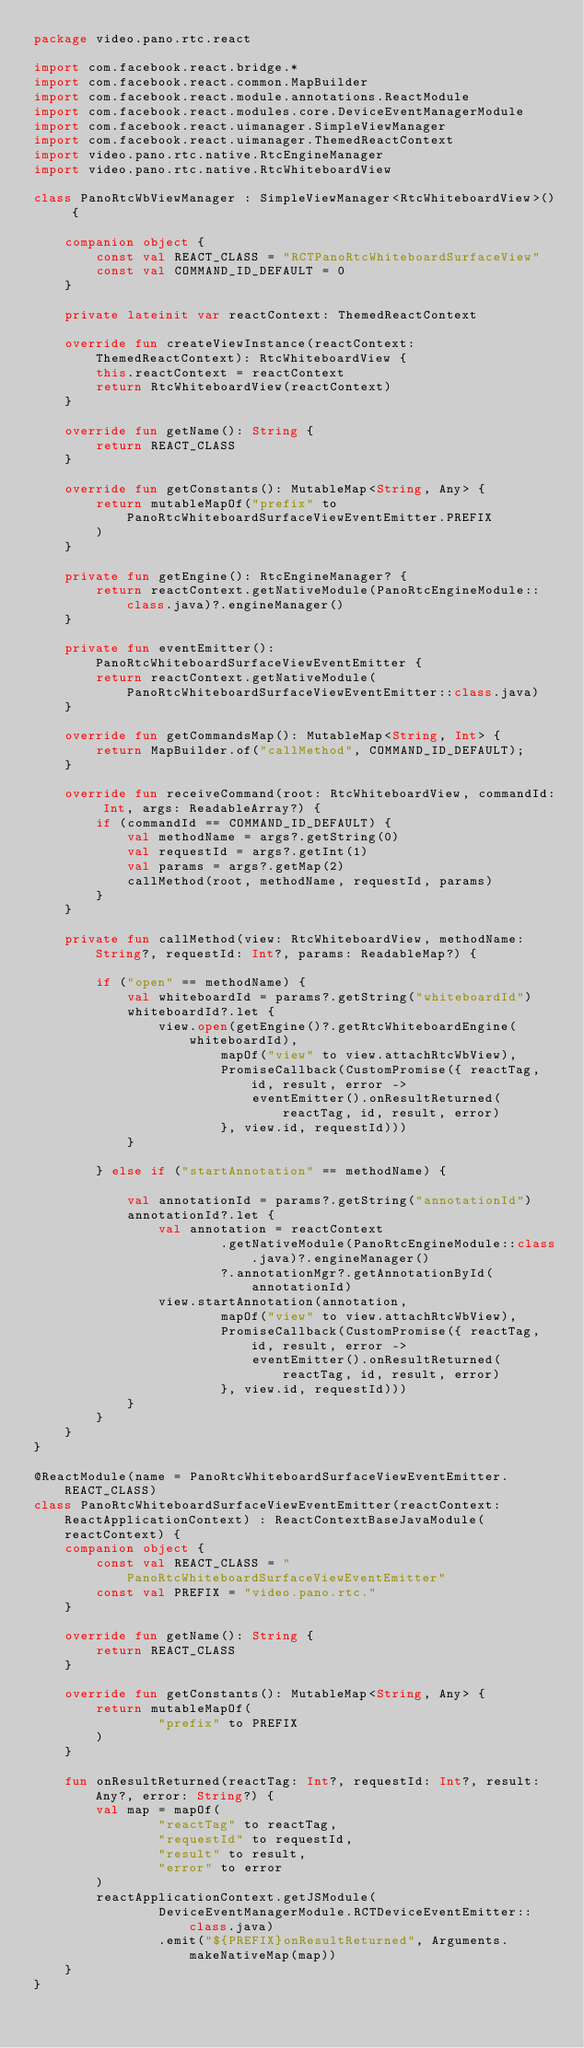<code> <loc_0><loc_0><loc_500><loc_500><_Kotlin_>package video.pano.rtc.react

import com.facebook.react.bridge.*
import com.facebook.react.common.MapBuilder
import com.facebook.react.module.annotations.ReactModule
import com.facebook.react.modules.core.DeviceEventManagerModule
import com.facebook.react.uimanager.SimpleViewManager
import com.facebook.react.uimanager.ThemedReactContext
import video.pano.rtc.native.RtcEngineManager
import video.pano.rtc.native.RtcWhiteboardView

class PanoRtcWbViewManager : SimpleViewManager<RtcWhiteboardView>() {

    companion object {
        const val REACT_CLASS = "RCTPanoRtcWhiteboardSurfaceView"
        const val COMMAND_ID_DEFAULT = 0
    }

    private lateinit var reactContext: ThemedReactContext

    override fun createViewInstance(reactContext: ThemedReactContext): RtcWhiteboardView {
        this.reactContext = reactContext
        return RtcWhiteboardView(reactContext)
    }

    override fun getName(): String {
        return REACT_CLASS
    }

    override fun getConstants(): MutableMap<String, Any> {
        return mutableMapOf("prefix" to PanoRtcWhiteboardSurfaceViewEventEmitter.PREFIX
        )
    }

    private fun getEngine(): RtcEngineManager? {
        return reactContext.getNativeModule(PanoRtcEngineModule::class.java)?.engineManager()
    }

    private fun eventEmitter(): PanoRtcWhiteboardSurfaceViewEventEmitter {
        return reactContext.getNativeModule(PanoRtcWhiteboardSurfaceViewEventEmitter::class.java)
    }

    override fun getCommandsMap(): MutableMap<String, Int> {
        return MapBuilder.of("callMethod", COMMAND_ID_DEFAULT);
    }

    override fun receiveCommand(root: RtcWhiteboardView, commandId: Int, args: ReadableArray?) {
        if (commandId == COMMAND_ID_DEFAULT) {
            val methodName = args?.getString(0)
            val requestId = args?.getInt(1)
            val params = args?.getMap(2)
            callMethod(root, methodName, requestId, params)
        }
    }

    private fun callMethod(view: RtcWhiteboardView, methodName: String?, requestId: Int?, params: ReadableMap?) {

        if ("open" == methodName) {
            val whiteboardId = params?.getString("whiteboardId")
            whiteboardId?.let {
                view.open(getEngine()?.getRtcWhiteboardEngine(whiteboardId),
                        mapOf("view" to view.attachRtcWbView),
                        PromiseCallback(CustomPromise({ reactTag, id, result, error ->
                            eventEmitter().onResultReturned(reactTag, id, result, error)
                        }, view.id, requestId)))
            }

        } else if ("startAnnotation" == methodName) {

            val annotationId = params?.getString("annotationId")
            annotationId?.let {
                val annotation = reactContext
                        .getNativeModule(PanoRtcEngineModule::class.java)?.engineManager()
                        ?.annotationMgr?.getAnnotationById(annotationId)
                view.startAnnotation(annotation,
                        mapOf("view" to view.attachRtcWbView),
                        PromiseCallback(CustomPromise({ reactTag, id, result, error ->
                            eventEmitter().onResultReturned(reactTag, id, result, error)
                        }, view.id, requestId)))
            }
        }
    }
}

@ReactModule(name = PanoRtcWhiteboardSurfaceViewEventEmitter.REACT_CLASS)
class PanoRtcWhiteboardSurfaceViewEventEmitter(reactContext: ReactApplicationContext) : ReactContextBaseJavaModule(reactContext) {
    companion object {
        const val REACT_CLASS = "PanoRtcWhiteboardSurfaceViewEventEmitter"
        const val PREFIX = "video.pano.rtc."
    }

    override fun getName(): String {
        return REACT_CLASS
    }

    override fun getConstants(): MutableMap<String, Any> {
        return mutableMapOf(
                "prefix" to PREFIX
        )
    }

    fun onResultReturned(reactTag: Int?, requestId: Int?, result: Any?, error: String?) {
        val map = mapOf(
                "reactTag" to reactTag,
                "requestId" to requestId,
                "result" to result,
                "error" to error
        )
        reactApplicationContext.getJSModule(
                DeviceEventManagerModule.RCTDeviceEventEmitter::class.java)
                .emit("${PREFIX}onResultReturned", Arguments.makeNativeMap(map))
    }
}</code> 